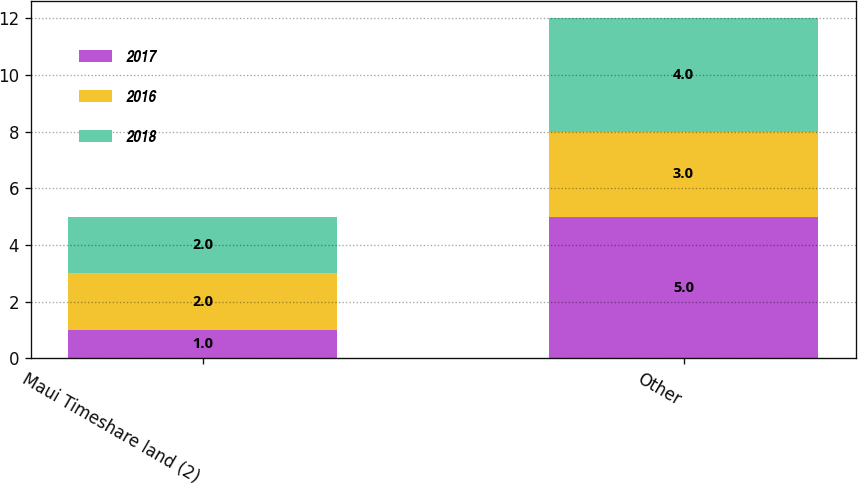<chart> <loc_0><loc_0><loc_500><loc_500><stacked_bar_chart><ecel><fcel>Maui Timeshare land (2)<fcel>Other<nl><fcel>2017<fcel>1<fcel>5<nl><fcel>2016<fcel>2<fcel>3<nl><fcel>2018<fcel>2<fcel>4<nl></chart> 